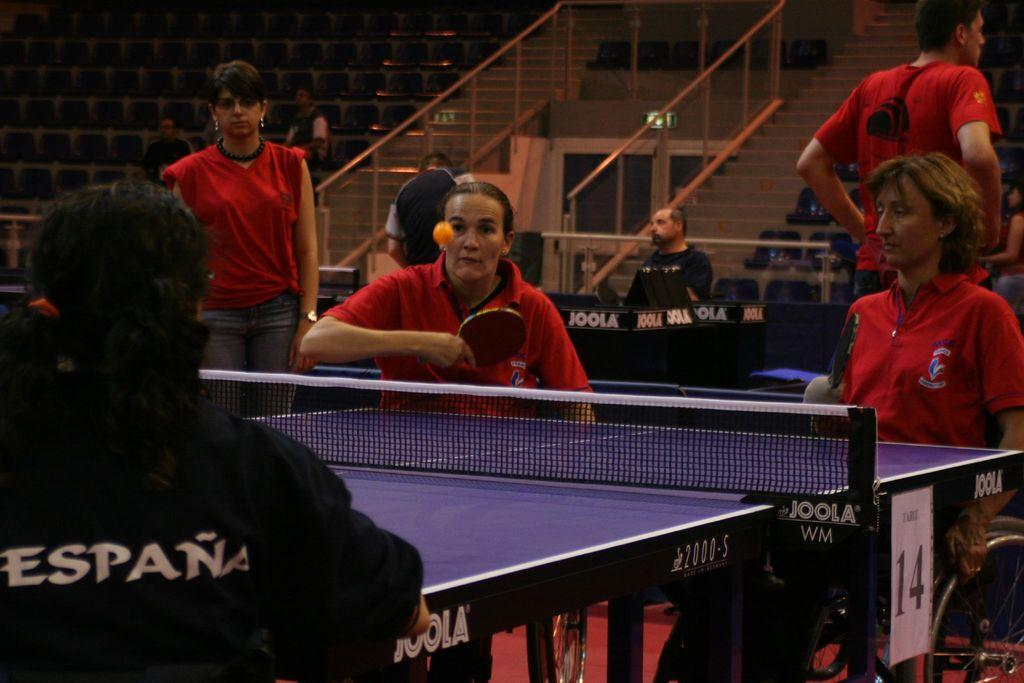What activity are the handicapped people engaged in? The handicapped people are playing table tennis. Can you describe the people in the background? There are other people in the background, but their specific actions or activities are not mentioned in the facts. How do the handicapped people maintain their balance during the earthquake in the image? There is no mention of an earthquake in the image, so it is not possible to answer this question. 